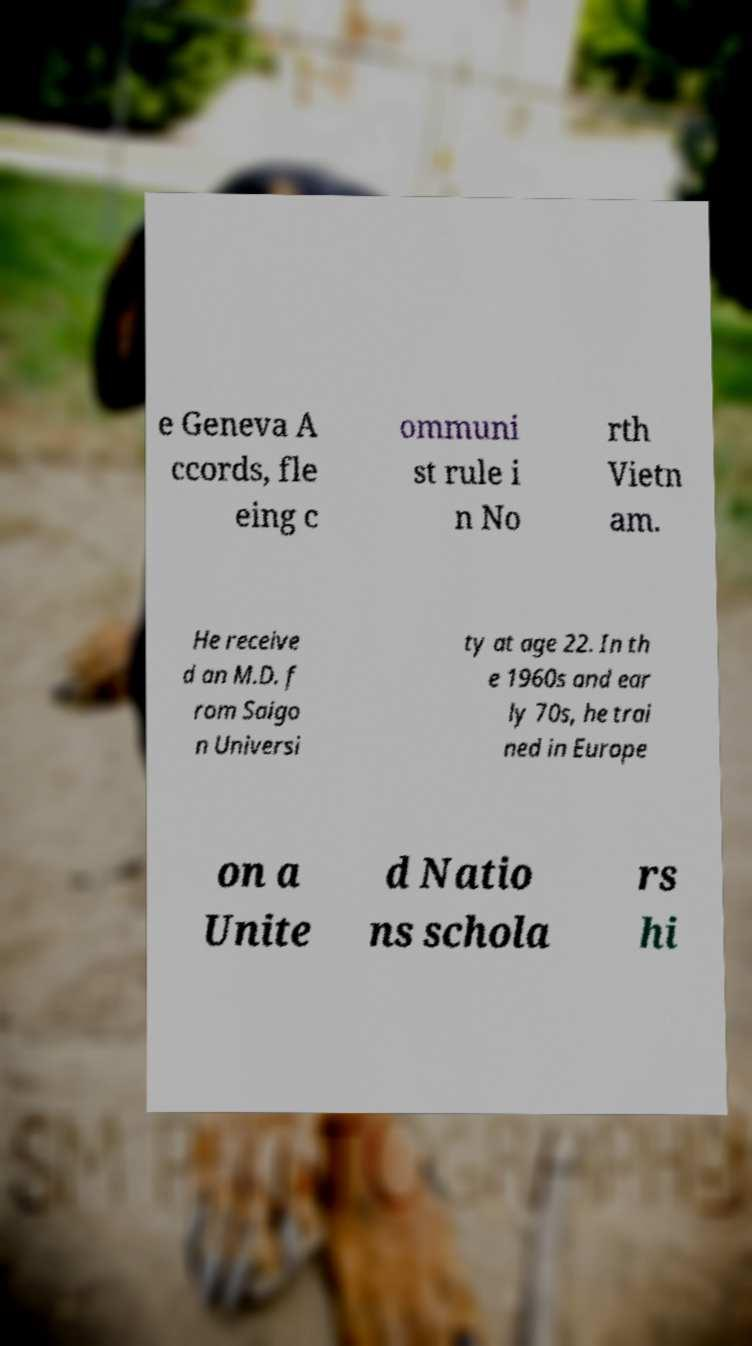Please read and relay the text visible in this image. What does it say? e Geneva A ccords, fle eing c ommuni st rule i n No rth Vietn am. He receive d an M.D. f rom Saigo n Universi ty at age 22. In th e 1960s and ear ly 70s, he trai ned in Europe on a Unite d Natio ns schola rs hi 